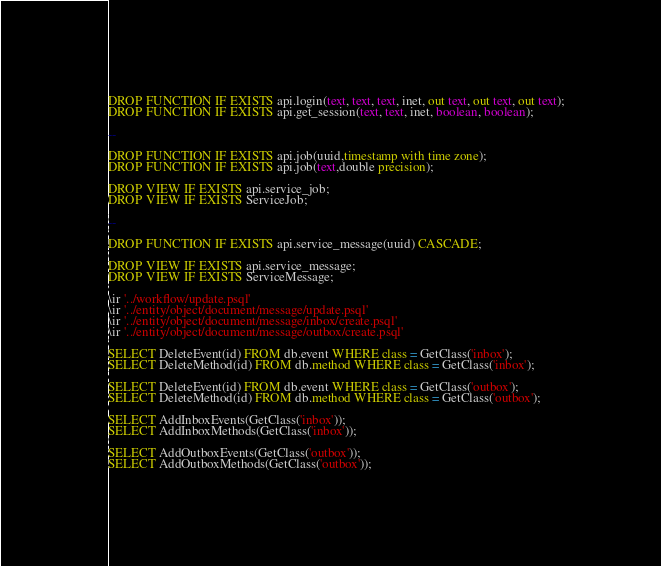<code> <loc_0><loc_0><loc_500><loc_500><_SQL_>DROP FUNCTION IF EXISTS api.login(text, text, text, inet, out text, out text, out text);
DROP FUNCTION IF EXISTS api.get_session(text, text, inet, boolean, boolean);

--

DROP FUNCTION IF EXISTS api.job(uuid,timestamp with time zone);
DROP FUNCTION IF EXISTS api.job(text,double precision);

DROP VIEW IF EXISTS api.service_job;
DROP VIEW IF EXISTS ServiceJob;

--

DROP FUNCTION IF EXISTS api.service_message(uuid) CASCADE;

DROP VIEW IF EXISTS api.service_message;
DROP VIEW IF EXISTS ServiceMessage;

\ir '../workflow/update.psql'
\ir '../entity/object/document/message/update.psql'
\ir '../entity/object/document/message/inbox/create.psql'
\ir '../entity/object/document/message/outbox/create.psql'

SELECT DeleteEvent(id) FROM db.event WHERE class = GetClass('inbox');
SELECT DeleteMethod(id) FROM db.method WHERE class = GetClass('inbox');

SELECT DeleteEvent(id) FROM db.event WHERE class = GetClass('outbox');
SELECT DeleteMethod(id) FROM db.method WHERE class = GetClass('outbox');

SELECT AddInboxEvents(GetClass('inbox'));
SELECT AddInboxMethods(GetClass('inbox'));

SELECT AddOutboxEvents(GetClass('outbox'));
SELECT AddOutboxMethods(GetClass('outbox'));
</code> 